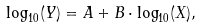<formula> <loc_0><loc_0><loc_500><loc_500>\log _ { 1 0 } ( Y ) = A + B \cdot \log _ { 1 0 } ( X ) ,</formula> 